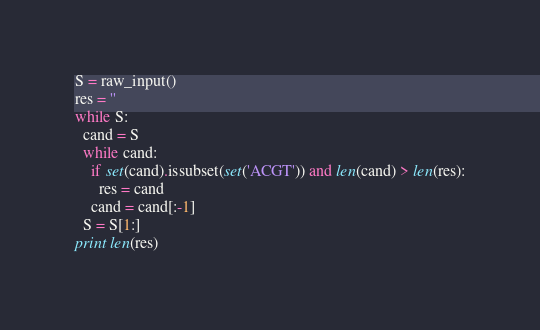Convert code to text. <code><loc_0><loc_0><loc_500><loc_500><_Python_>S = raw_input()
res = ''
while S:
  cand = S
  while cand:
    if set(cand).issubset(set('ACGT')) and len(cand) > len(res):
      res = cand
    cand = cand[:-1]
  S = S[1:]
print len(res)</code> 